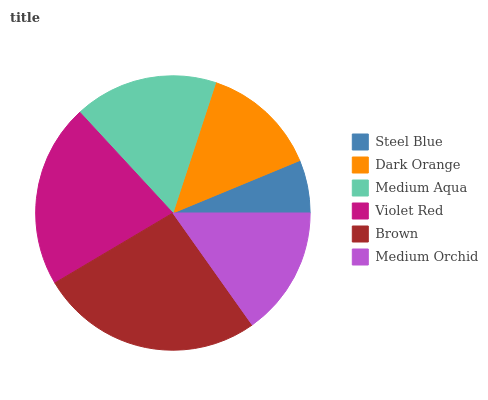Is Steel Blue the minimum?
Answer yes or no. Yes. Is Brown the maximum?
Answer yes or no. Yes. Is Dark Orange the minimum?
Answer yes or no. No. Is Dark Orange the maximum?
Answer yes or no. No. Is Dark Orange greater than Steel Blue?
Answer yes or no. Yes. Is Steel Blue less than Dark Orange?
Answer yes or no. Yes. Is Steel Blue greater than Dark Orange?
Answer yes or no. No. Is Dark Orange less than Steel Blue?
Answer yes or no. No. Is Medium Aqua the high median?
Answer yes or no. Yes. Is Medium Orchid the low median?
Answer yes or no. Yes. Is Steel Blue the high median?
Answer yes or no. No. Is Brown the low median?
Answer yes or no. No. 